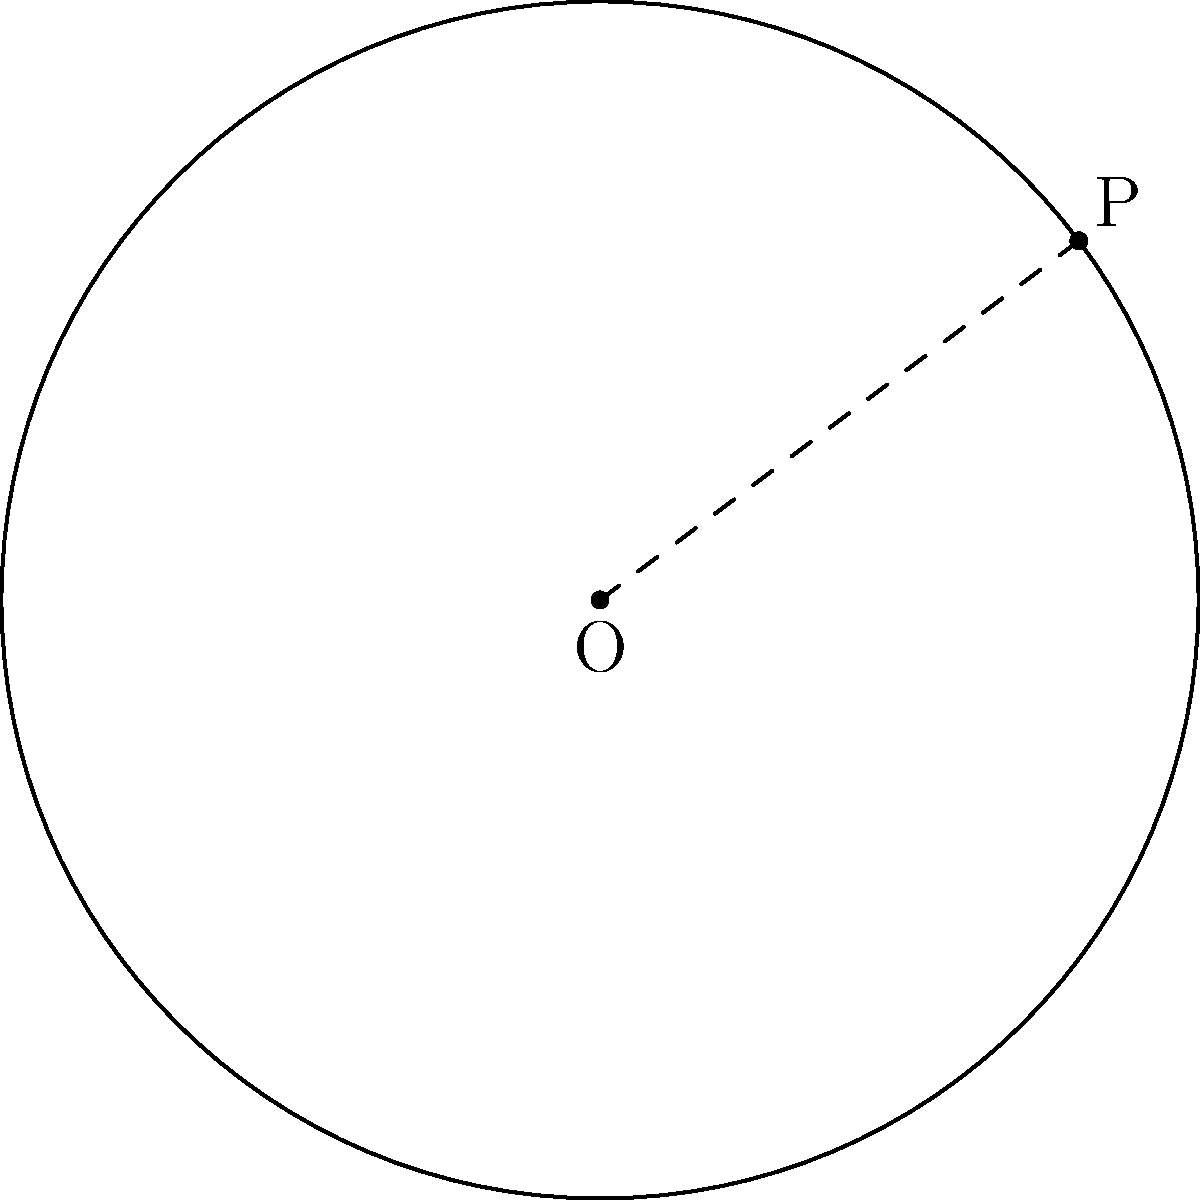At Sheikh Russel Krira Chakra's training ground, a circular field has its center at the origin (0,0) and a point P(4,3) on its circumference. Calculate the area of this circular field in square meters. Let's approach this step-by-step:

1) To find the area of a circle, we need its radius. We can calculate this using the distance formula between the center O(0,0) and the point P(4,3) on the circumference.

2) The distance formula is:
   $$r = \sqrt{(x_2-x_1)^2 + (y_2-y_1)^2}$$

3) Plugging in our values:
   $$r = \sqrt{(4-0)^2 + (3-0)^2} = \sqrt{16 + 9} = \sqrt{25} = 5$$

4) Now that we have the radius, we can use the formula for the area of a circle:
   $$A = \pi r^2$$

5) Substituting our radius:
   $$A = \pi (5)^2 = 25\pi$$

6) Therefore, the area of the circular field is $25\pi$ square meters.
Answer: $25\pi$ m² 